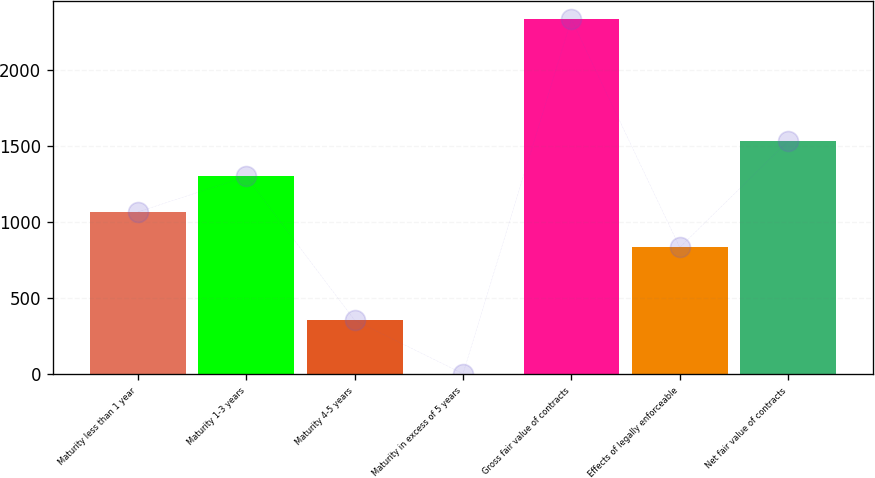Convert chart. <chart><loc_0><loc_0><loc_500><loc_500><bar_chart><fcel>Maturity less than 1 year<fcel>Maturity 1-3 years<fcel>Maturity 4-5 years<fcel>Maturity in excess of 5 years<fcel>Gross fair value of contracts<fcel>Effects of legally enforceable<fcel>Net fair value of contracts<nl><fcel>1066.6<fcel>1299.2<fcel>356<fcel>5<fcel>2331<fcel>834<fcel>1531.8<nl></chart> 